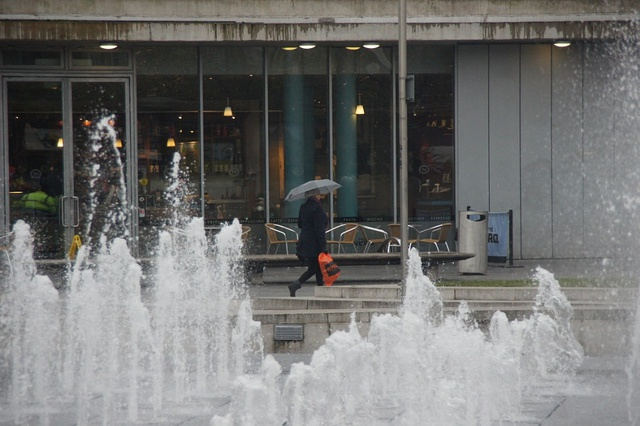Describe the objects in this image and their specific colors. I can see bench in black and gray tones, people in black, gray, and maroon tones, people in black and darkgreen tones, chair in black, gray, maroon, and purple tones, and chair in black, gray, and purple tones in this image. 